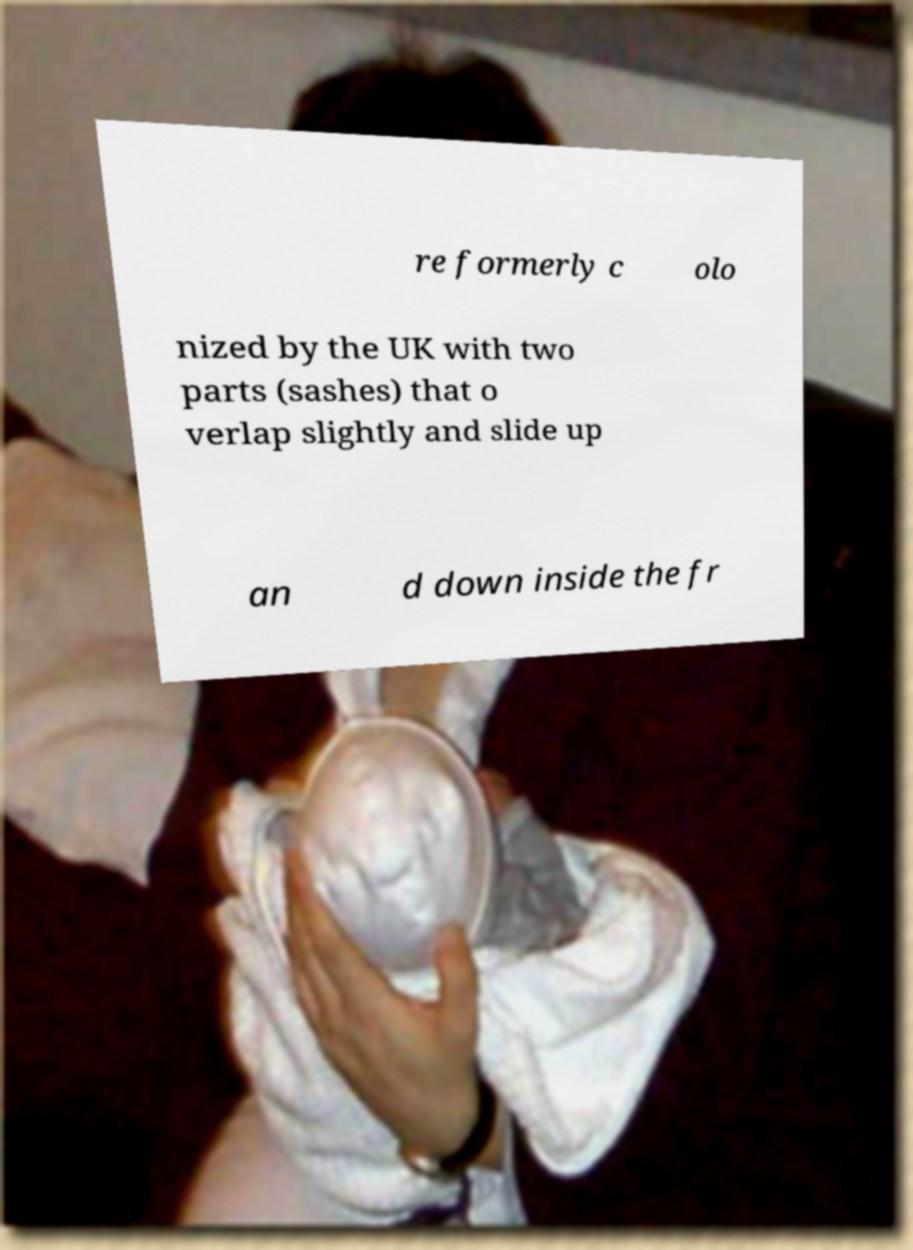Could you extract and type out the text from this image? re formerly c olo nized by the UK with two parts (sashes) that o verlap slightly and slide up an d down inside the fr 